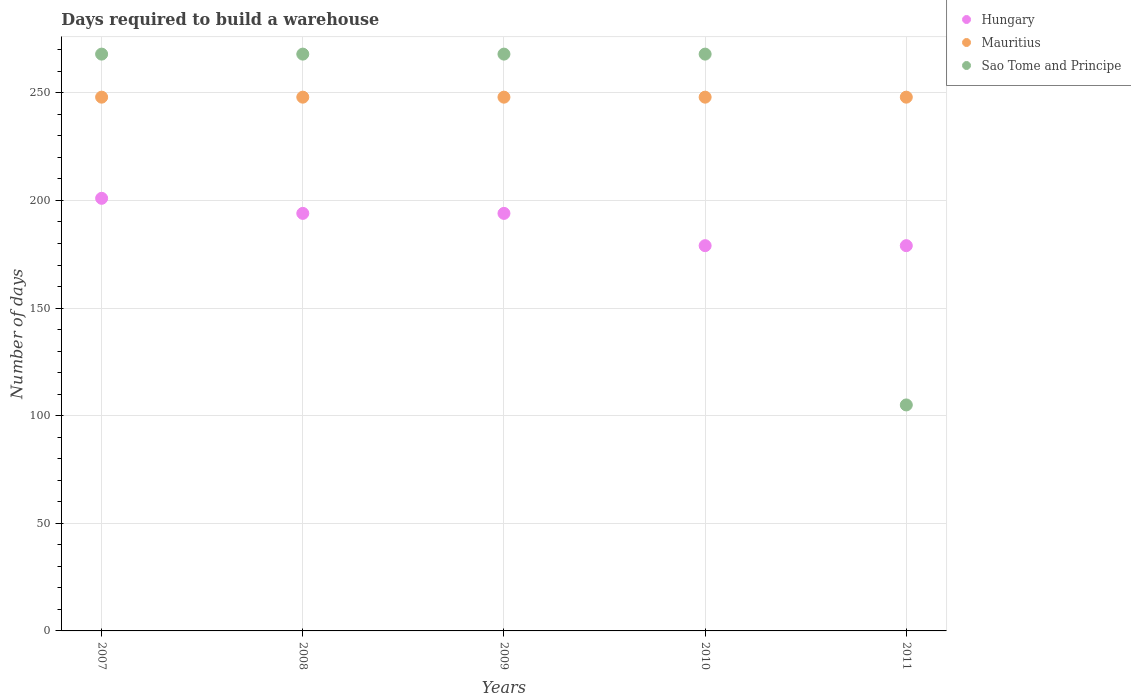How many different coloured dotlines are there?
Your answer should be compact. 3. What is the days required to build a warehouse in in Hungary in 2008?
Your answer should be very brief. 194. Across all years, what is the maximum days required to build a warehouse in in Hungary?
Ensure brevity in your answer.  201. Across all years, what is the minimum days required to build a warehouse in in Hungary?
Keep it short and to the point. 179. In which year was the days required to build a warehouse in in Sao Tome and Principe minimum?
Your answer should be very brief. 2011. What is the total days required to build a warehouse in in Mauritius in the graph?
Make the answer very short. 1240. What is the difference between the days required to build a warehouse in in Hungary in 2007 and that in 2008?
Offer a very short reply. 7. What is the difference between the days required to build a warehouse in in Mauritius in 2007 and the days required to build a warehouse in in Hungary in 2010?
Your answer should be very brief. 69. What is the average days required to build a warehouse in in Mauritius per year?
Make the answer very short. 248. In the year 2011, what is the difference between the days required to build a warehouse in in Sao Tome and Principe and days required to build a warehouse in in Mauritius?
Provide a succinct answer. -143. In how many years, is the days required to build a warehouse in in Hungary greater than 10 days?
Provide a succinct answer. 5. What is the ratio of the days required to build a warehouse in in Hungary in 2008 to that in 2009?
Make the answer very short. 1. Is the difference between the days required to build a warehouse in in Sao Tome and Principe in 2009 and 2011 greater than the difference between the days required to build a warehouse in in Mauritius in 2009 and 2011?
Provide a succinct answer. Yes. What is the difference between the highest and the second highest days required to build a warehouse in in Sao Tome and Principe?
Your answer should be very brief. 0. In how many years, is the days required to build a warehouse in in Mauritius greater than the average days required to build a warehouse in in Mauritius taken over all years?
Make the answer very short. 0. Does the days required to build a warehouse in in Mauritius monotonically increase over the years?
Offer a terse response. No. Is the days required to build a warehouse in in Mauritius strictly greater than the days required to build a warehouse in in Sao Tome and Principe over the years?
Your response must be concise. No. Is the days required to build a warehouse in in Sao Tome and Principe strictly less than the days required to build a warehouse in in Mauritius over the years?
Provide a succinct answer. No. How many dotlines are there?
Provide a succinct answer. 3. Are the values on the major ticks of Y-axis written in scientific E-notation?
Your response must be concise. No. Does the graph contain any zero values?
Provide a short and direct response. No. Does the graph contain grids?
Your answer should be very brief. Yes. How many legend labels are there?
Your response must be concise. 3. What is the title of the graph?
Make the answer very short. Days required to build a warehouse. Does "Europe(all income levels)" appear as one of the legend labels in the graph?
Keep it short and to the point. No. What is the label or title of the X-axis?
Offer a terse response. Years. What is the label or title of the Y-axis?
Offer a very short reply. Number of days. What is the Number of days in Hungary in 2007?
Provide a short and direct response. 201. What is the Number of days in Mauritius in 2007?
Provide a succinct answer. 248. What is the Number of days of Sao Tome and Principe in 2007?
Make the answer very short. 268. What is the Number of days of Hungary in 2008?
Offer a very short reply. 194. What is the Number of days in Mauritius in 2008?
Your answer should be compact. 248. What is the Number of days in Sao Tome and Principe in 2008?
Make the answer very short. 268. What is the Number of days of Hungary in 2009?
Provide a succinct answer. 194. What is the Number of days in Mauritius in 2009?
Offer a terse response. 248. What is the Number of days in Sao Tome and Principe in 2009?
Your answer should be compact. 268. What is the Number of days of Hungary in 2010?
Your answer should be very brief. 179. What is the Number of days of Mauritius in 2010?
Make the answer very short. 248. What is the Number of days of Sao Tome and Principe in 2010?
Ensure brevity in your answer.  268. What is the Number of days in Hungary in 2011?
Ensure brevity in your answer.  179. What is the Number of days in Mauritius in 2011?
Make the answer very short. 248. What is the Number of days in Sao Tome and Principe in 2011?
Give a very brief answer. 105. Across all years, what is the maximum Number of days in Hungary?
Give a very brief answer. 201. Across all years, what is the maximum Number of days of Mauritius?
Ensure brevity in your answer.  248. Across all years, what is the maximum Number of days in Sao Tome and Principe?
Your answer should be very brief. 268. Across all years, what is the minimum Number of days in Hungary?
Your answer should be very brief. 179. Across all years, what is the minimum Number of days of Mauritius?
Your response must be concise. 248. Across all years, what is the minimum Number of days in Sao Tome and Principe?
Your answer should be very brief. 105. What is the total Number of days of Hungary in the graph?
Offer a terse response. 947. What is the total Number of days of Mauritius in the graph?
Keep it short and to the point. 1240. What is the total Number of days in Sao Tome and Principe in the graph?
Make the answer very short. 1177. What is the difference between the Number of days of Hungary in 2007 and that in 2008?
Give a very brief answer. 7. What is the difference between the Number of days of Sao Tome and Principe in 2007 and that in 2008?
Offer a terse response. 0. What is the difference between the Number of days of Hungary in 2007 and that in 2009?
Provide a succinct answer. 7. What is the difference between the Number of days of Sao Tome and Principe in 2007 and that in 2009?
Your answer should be very brief. 0. What is the difference between the Number of days of Hungary in 2007 and that in 2010?
Keep it short and to the point. 22. What is the difference between the Number of days in Mauritius in 2007 and that in 2010?
Offer a terse response. 0. What is the difference between the Number of days of Sao Tome and Principe in 2007 and that in 2010?
Your answer should be compact. 0. What is the difference between the Number of days of Hungary in 2007 and that in 2011?
Keep it short and to the point. 22. What is the difference between the Number of days in Sao Tome and Principe in 2007 and that in 2011?
Provide a short and direct response. 163. What is the difference between the Number of days of Mauritius in 2008 and that in 2010?
Give a very brief answer. 0. What is the difference between the Number of days in Sao Tome and Principe in 2008 and that in 2010?
Provide a short and direct response. 0. What is the difference between the Number of days in Sao Tome and Principe in 2008 and that in 2011?
Your answer should be compact. 163. What is the difference between the Number of days in Sao Tome and Principe in 2009 and that in 2010?
Offer a terse response. 0. What is the difference between the Number of days of Hungary in 2009 and that in 2011?
Keep it short and to the point. 15. What is the difference between the Number of days in Mauritius in 2009 and that in 2011?
Offer a very short reply. 0. What is the difference between the Number of days in Sao Tome and Principe in 2009 and that in 2011?
Give a very brief answer. 163. What is the difference between the Number of days in Hungary in 2010 and that in 2011?
Keep it short and to the point. 0. What is the difference between the Number of days of Sao Tome and Principe in 2010 and that in 2011?
Give a very brief answer. 163. What is the difference between the Number of days in Hungary in 2007 and the Number of days in Mauritius in 2008?
Your answer should be very brief. -47. What is the difference between the Number of days of Hungary in 2007 and the Number of days of Sao Tome and Principe in 2008?
Your answer should be very brief. -67. What is the difference between the Number of days in Hungary in 2007 and the Number of days in Mauritius in 2009?
Ensure brevity in your answer.  -47. What is the difference between the Number of days in Hungary in 2007 and the Number of days in Sao Tome and Principe in 2009?
Ensure brevity in your answer.  -67. What is the difference between the Number of days in Hungary in 2007 and the Number of days in Mauritius in 2010?
Offer a terse response. -47. What is the difference between the Number of days in Hungary in 2007 and the Number of days in Sao Tome and Principe in 2010?
Provide a succinct answer. -67. What is the difference between the Number of days of Hungary in 2007 and the Number of days of Mauritius in 2011?
Provide a succinct answer. -47. What is the difference between the Number of days of Hungary in 2007 and the Number of days of Sao Tome and Principe in 2011?
Your response must be concise. 96. What is the difference between the Number of days in Mauritius in 2007 and the Number of days in Sao Tome and Principe in 2011?
Make the answer very short. 143. What is the difference between the Number of days in Hungary in 2008 and the Number of days in Mauritius in 2009?
Offer a very short reply. -54. What is the difference between the Number of days in Hungary in 2008 and the Number of days in Sao Tome and Principe in 2009?
Offer a terse response. -74. What is the difference between the Number of days of Mauritius in 2008 and the Number of days of Sao Tome and Principe in 2009?
Your answer should be compact. -20. What is the difference between the Number of days of Hungary in 2008 and the Number of days of Mauritius in 2010?
Your answer should be very brief. -54. What is the difference between the Number of days in Hungary in 2008 and the Number of days in Sao Tome and Principe in 2010?
Give a very brief answer. -74. What is the difference between the Number of days in Hungary in 2008 and the Number of days in Mauritius in 2011?
Offer a terse response. -54. What is the difference between the Number of days in Hungary in 2008 and the Number of days in Sao Tome and Principe in 2011?
Offer a terse response. 89. What is the difference between the Number of days in Mauritius in 2008 and the Number of days in Sao Tome and Principe in 2011?
Make the answer very short. 143. What is the difference between the Number of days in Hungary in 2009 and the Number of days in Mauritius in 2010?
Your answer should be compact. -54. What is the difference between the Number of days of Hungary in 2009 and the Number of days of Sao Tome and Principe in 2010?
Make the answer very short. -74. What is the difference between the Number of days in Mauritius in 2009 and the Number of days in Sao Tome and Principe in 2010?
Ensure brevity in your answer.  -20. What is the difference between the Number of days of Hungary in 2009 and the Number of days of Mauritius in 2011?
Your response must be concise. -54. What is the difference between the Number of days in Hungary in 2009 and the Number of days in Sao Tome and Principe in 2011?
Offer a very short reply. 89. What is the difference between the Number of days of Mauritius in 2009 and the Number of days of Sao Tome and Principe in 2011?
Provide a succinct answer. 143. What is the difference between the Number of days of Hungary in 2010 and the Number of days of Mauritius in 2011?
Provide a succinct answer. -69. What is the difference between the Number of days in Hungary in 2010 and the Number of days in Sao Tome and Principe in 2011?
Ensure brevity in your answer.  74. What is the difference between the Number of days in Mauritius in 2010 and the Number of days in Sao Tome and Principe in 2011?
Give a very brief answer. 143. What is the average Number of days in Hungary per year?
Your answer should be very brief. 189.4. What is the average Number of days of Mauritius per year?
Offer a very short reply. 248. What is the average Number of days of Sao Tome and Principe per year?
Provide a short and direct response. 235.4. In the year 2007, what is the difference between the Number of days in Hungary and Number of days in Mauritius?
Your answer should be compact. -47. In the year 2007, what is the difference between the Number of days of Hungary and Number of days of Sao Tome and Principe?
Your answer should be compact. -67. In the year 2007, what is the difference between the Number of days in Mauritius and Number of days in Sao Tome and Principe?
Offer a very short reply. -20. In the year 2008, what is the difference between the Number of days in Hungary and Number of days in Mauritius?
Offer a very short reply. -54. In the year 2008, what is the difference between the Number of days of Hungary and Number of days of Sao Tome and Principe?
Keep it short and to the point. -74. In the year 2008, what is the difference between the Number of days of Mauritius and Number of days of Sao Tome and Principe?
Give a very brief answer. -20. In the year 2009, what is the difference between the Number of days of Hungary and Number of days of Mauritius?
Provide a short and direct response. -54. In the year 2009, what is the difference between the Number of days of Hungary and Number of days of Sao Tome and Principe?
Give a very brief answer. -74. In the year 2010, what is the difference between the Number of days in Hungary and Number of days in Mauritius?
Offer a terse response. -69. In the year 2010, what is the difference between the Number of days in Hungary and Number of days in Sao Tome and Principe?
Ensure brevity in your answer.  -89. In the year 2011, what is the difference between the Number of days of Hungary and Number of days of Mauritius?
Make the answer very short. -69. In the year 2011, what is the difference between the Number of days in Hungary and Number of days in Sao Tome and Principe?
Offer a very short reply. 74. In the year 2011, what is the difference between the Number of days of Mauritius and Number of days of Sao Tome and Principe?
Provide a succinct answer. 143. What is the ratio of the Number of days in Hungary in 2007 to that in 2008?
Give a very brief answer. 1.04. What is the ratio of the Number of days in Mauritius in 2007 to that in 2008?
Your answer should be very brief. 1. What is the ratio of the Number of days of Sao Tome and Principe in 2007 to that in 2008?
Offer a very short reply. 1. What is the ratio of the Number of days in Hungary in 2007 to that in 2009?
Make the answer very short. 1.04. What is the ratio of the Number of days of Mauritius in 2007 to that in 2009?
Your answer should be very brief. 1. What is the ratio of the Number of days of Hungary in 2007 to that in 2010?
Your response must be concise. 1.12. What is the ratio of the Number of days in Hungary in 2007 to that in 2011?
Provide a short and direct response. 1.12. What is the ratio of the Number of days of Sao Tome and Principe in 2007 to that in 2011?
Provide a succinct answer. 2.55. What is the ratio of the Number of days of Hungary in 2008 to that in 2010?
Provide a succinct answer. 1.08. What is the ratio of the Number of days in Mauritius in 2008 to that in 2010?
Provide a short and direct response. 1. What is the ratio of the Number of days in Hungary in 2008 to that in 2011?
Make the answer very short. 1.08. What is the ratio of the Number of days in Mauritius in 2008 to that in 2011?
Provide a succinct answer. 1. What is the ratio of the Number of days in Sao Tome and Principe in 2008 to that in 2011?
Your response must be concise. 2.55. What is the ratio of the Number of days in Hungary in 2009 to that in 2010?
Ensure brevity in your answer.  1.08. What is the ratio of the Number of days of Mauritius in 2009 to that in 2010?
Provide a short and direct response. 1. What is the ratio of the Number of days in Hungary in 2009 to that in 2011?
Offer a very short reply. 1.08. What is the ratio of the Number of days of Mauritius in 2009 to that in 2011?
Your response must be concise. 1. What is the ratio of the Number of days in Sao Tome and Principe in 2009 to that in 2011?
Make the answer very short. 2.55. What is the ratio of the Number of days of Hungary in 2010 to that in 2011?
Ensure brevity in your answer.  1. What is the ratio of the Number of days of Sao Tome and Principe in 2010 to that in 2011?
Keep it short and to the point. 2.55. What is the difference between the highest and the second highest Number of days of Hungary?
Provide a succinct answer. 7. What is the difference between the highest and the second highest Number of days in Sao Tome and Principe?
Provide a short and direct response. 0. What is the difference between the highest and the lowest Number of days in Hungary?
Ensure brevity in your answer.  22. What is the difference between the highest and the lowest Number of days in Mauritius?
Your response must be concise. 0. What is the difference between the highest and the lowest Number of days in Sao Tome and Principe?
Your answer should be compact. 163. 